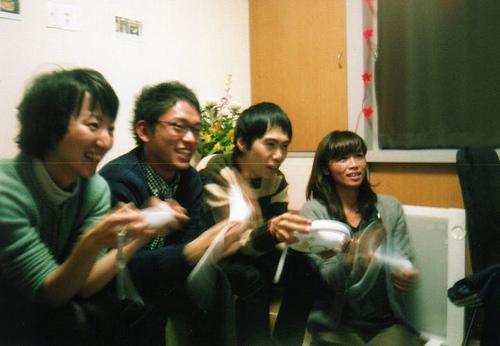How many guys in the picture?
Give a very brief answer. 2. How many girls in the picure?
Give a very brief answer. 2. How many people wearing glasses?
Give a very brief answer. 1. 